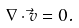Convert formula to latex. <formula><loc_0><loc_0><loc_500><loc_500>\nabla \cdot \vec { v } = 0 .</formula> 